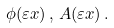Convert formula to latex. <formula><loc_0><loc_0><loc_500><loc_500>\phi ( \varepsilon x ) \, , \, A ( \varepsilon x ) \, .</formula> 